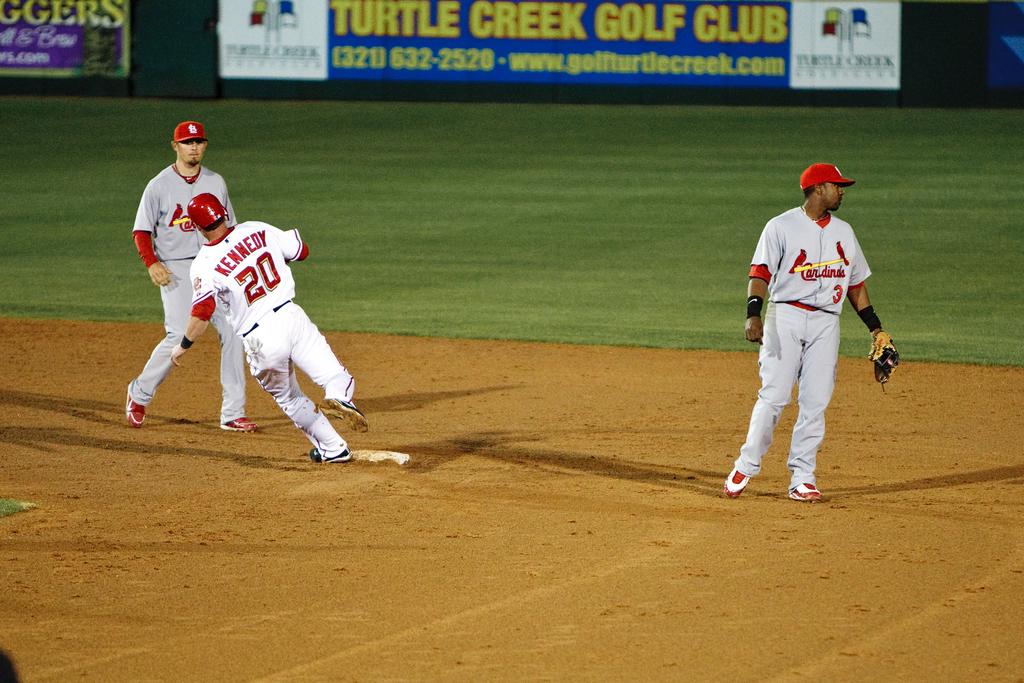What is kennedy's player number?
Your response must be concise. 20. 